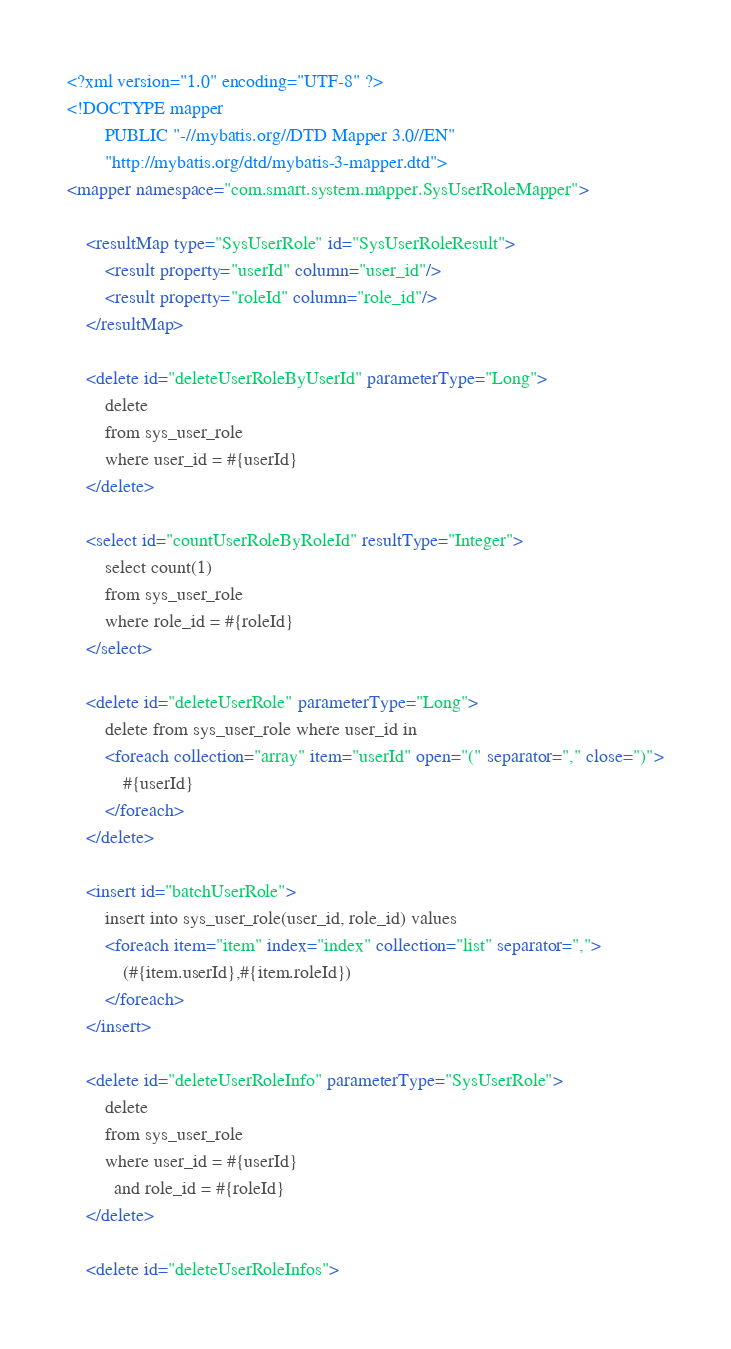Convert code to text. <code><loc_0><loc_0><loc_500><loc_500><_XML_><?xml version="1.0" encoding="UTF-8" ?>
<!DOCTYPE mapper
        PUBLIC "-//mybatis.org//DTD Mapper 3.0//EN"
        "http://mybatis.org/dtd/mybatis-3-mapper.dtd">
<mapper namespace="com.smart.system.mapper.SysUserRoleMapper">

    <resultMap type="SysUserRole" id="SysUserRoleResult">
        <result property="userId" column="user_id"/>
        <result property="roleId" column="role_id"/>
    </resultMap>

    <delete id="deleteUserRoleByUserId" parameterType="Long">
        delete
        from sys_user_role
        where user_id = #{userId}
    </delete>

    <select id="countUserRoleByRoleId" resultType="Integer">
        select count(1)
        from sys_user_role
        where role_id = #{roleId}
    </select>

    <delete id="deleteUserRole" parameterType="Long">
        delete from sys_user_role where user_id in
        <foreach collection="array" item="userId" open="(" separator="," close=")">
            #{userId}
        </foreach>
    </delete>

    <insert id="batchUserRole">
        insert into sys_user_role(user_id, role_id) values
        <foreach item="item" index="index" collection="list" separator=",">
            (#{item.userId},#{item.roleId})
        </foreach>
    </insert>

    <delete id="deleteUserRoleInfo" parameterType="SysUserRole">
        delete
        from sys_user_role
        where user_id = #{userId}
          and role_id = #{roleId}
    </delete>

    <delete id="deleteUserRoleInfos"></code> 